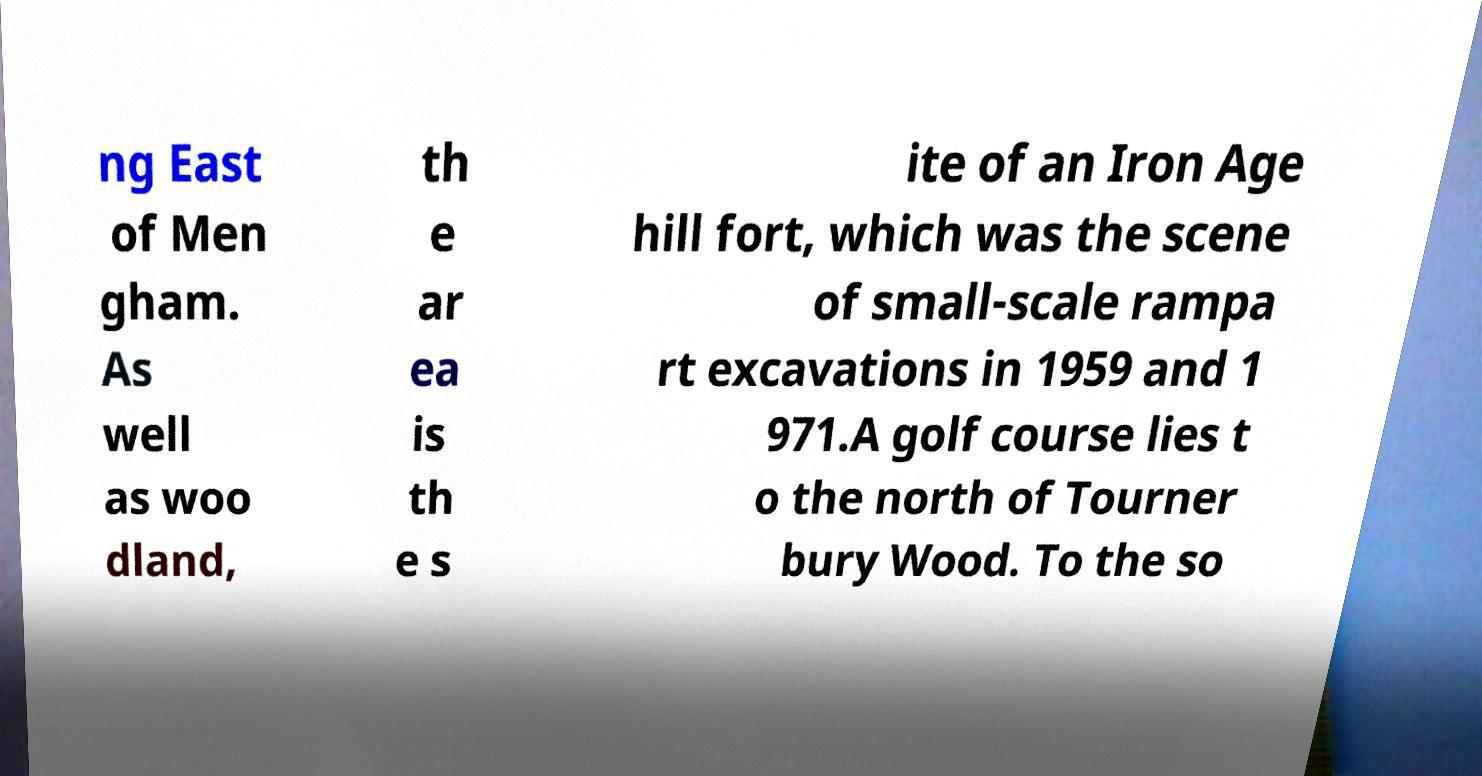Could you extract and type out the text from this image? ng East of Men gham. As well as woo dland, th e ar ea is th e s ite of an Iron Age hill fort, which was the scene of small-scale rampa rt excavations in 1959 and 1 971.A golf course lies t o the north of Tourner bury Wood. To the so 